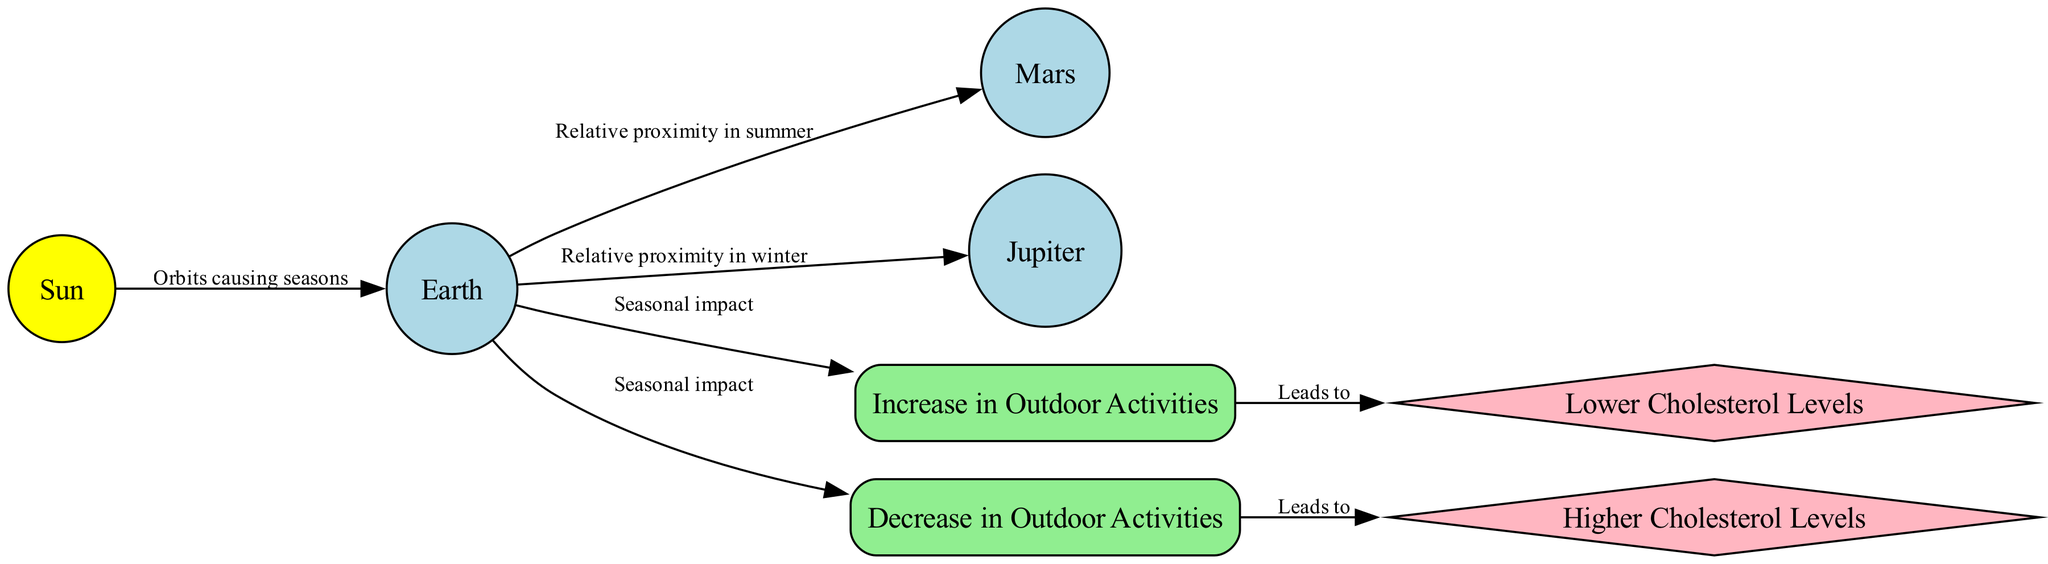What are the seasons represented in the diagram? The nodes related to seasons in the diagram are "Increase in Outdoor Activities" for summer and "Decrease in Outdoor Activities" for winter. These indicate the two seasons depicted.
Answer: summer, winter How many celestial bodies are in the diagram? The diagram contains one celestial body, which is the "Sun." This can be identified as the only node of the type "celestial_body."
Answer: 1 What is the relationship between the Earth and Mars according to the diagram? The edge connecting "Earth" and "Mars" is labeled "Relative proximity in summer," indicating that the diagram shows their relationship during the summer season.
Answer: Relative proximity in summer What health trend is associated with summer activities? The edge from "Increase in Outdoor Activities" to "Lower Cholesterol Levels" shows that these activities during summer lead to lower cholesterol levels.
Answer: Lower Cholesterol Levels What is the impact of winter activities on health? The diagram indicates that "Decrease in Outdoor Activities" is linked to "Higher Cholesterol Levels," showing the negative health trend tied to winter activities.
Answer: Higher Cholesterol Levels Which planet has a relationship with Earth during winter? The edge connecting "Earth" and "Jupiter" is labeled "Relative proximity in winter," signifying that Jupiter is the planet connected to Earth during winter.
Answer: Jupiter What type of node represents outdoor activities? The nodes "Increase in Outdoor Activities" and "Decrease in Outdoor Activities" are both of the type "activity_trend," which is represented as a box in the diagram.
Answer: activity_trend How do the seasonal effects impact cholesterol levels? The diagram shows a flow where "Increase in Outdoor Activities" leads to "Lower Cholesterol Levels," while "Decrease in Outdoor Activities" leads to "Higher Cholesterol Levels," indicating that seasonal changes have a direct effect on cholesterol levels based on physical activity.
Answer: Seasonal effects impact cholesterol levels through activity changes 